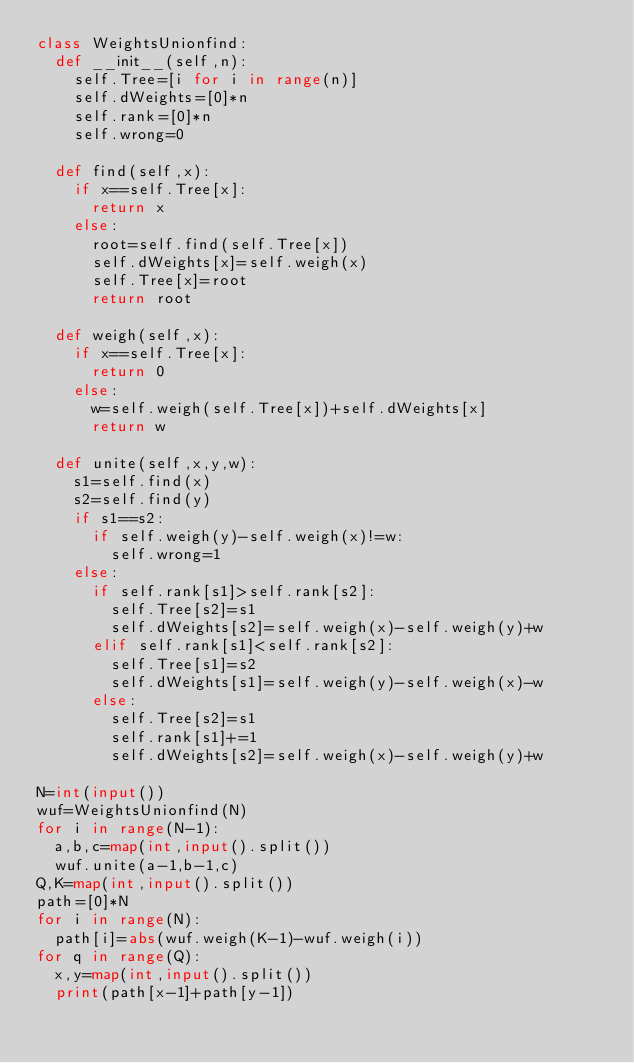<code> <loc_0><loc_0><loc_500><loc_500><_Python_>class WeightsUnionfind:
  def __init__(self,n):
    self.Tree=[i for i in range(n)]
    self.dWeights=[0]*n
    self.rank=[0]*n
    self.wrong=0

  def find(self,x):
    if x==self.Tree[x]:
      return x
    else:
      root=self.find(self.Tree[x])
      self.dWeights[x]=self.weigh(x)
      self.Tree[x]=root
      return root
  
  def weigh(self,x):
    if x==self.Tree[x]:
      return 0
    else:
      w=self.weigh(self.Tree[x])+self.dWeights[x]
      return w

  def unite(self,x,y,w):
    s1=self.find(x)
    s2=self.find(y)
    if s1==s2:
      if self.weigh(y)-self.weigh(x)!=w:
        self.wrong=1
    else:
      if self.rank[s1]>self.rank[s2]:
        self.Tree[s2]=s1
        self.dWeights[s2]=self.weigh(x)-self.weigh(y)+w
      elif self.rank[s1]<self.rank[s2]:
        self.Tree[s1]=s2
        self.dWeights[s1]=self.weigh(y)-self.weigh(x)-w
      else:
        self.Tree[s2]=s1
        self.rank[s1]+=1
        self.dWeights[s2]=self.weigh(x)-self.weigh(y)+w
          
N=int(input())
wuf=WeightsUnionfind(N)
for i in range(N-1):
  a,b,c=map(int,input().split())
  wuf.unite(a-1,b-1,c)
Q,K=map(int,input().split())
path=[0]*N
for i in range(N):
  path[i]=abs(wuf.weigh(K-1)-wuf.weigh(i))
for q in range(Q):
  x,y=map(int,input().split())
  print(path[x-1]+path[y-1])
  
      
    
      
      </code> 